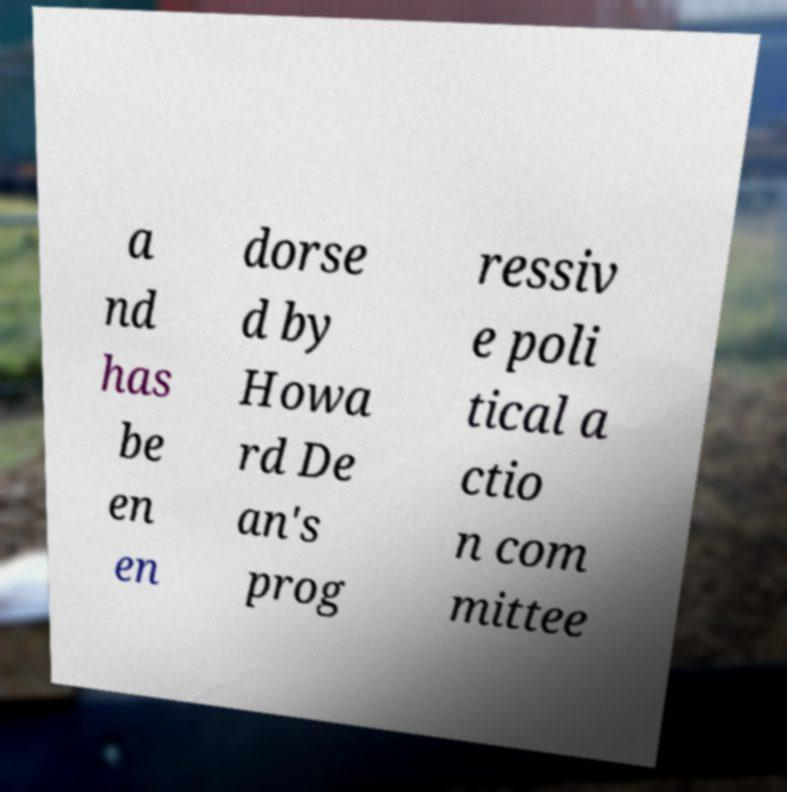Can you accurately transcribe the text from the provided image for me? a nd has be en en dorse d by Howa rd De an's prog ressiv e poli tical a ctio n com mittee 